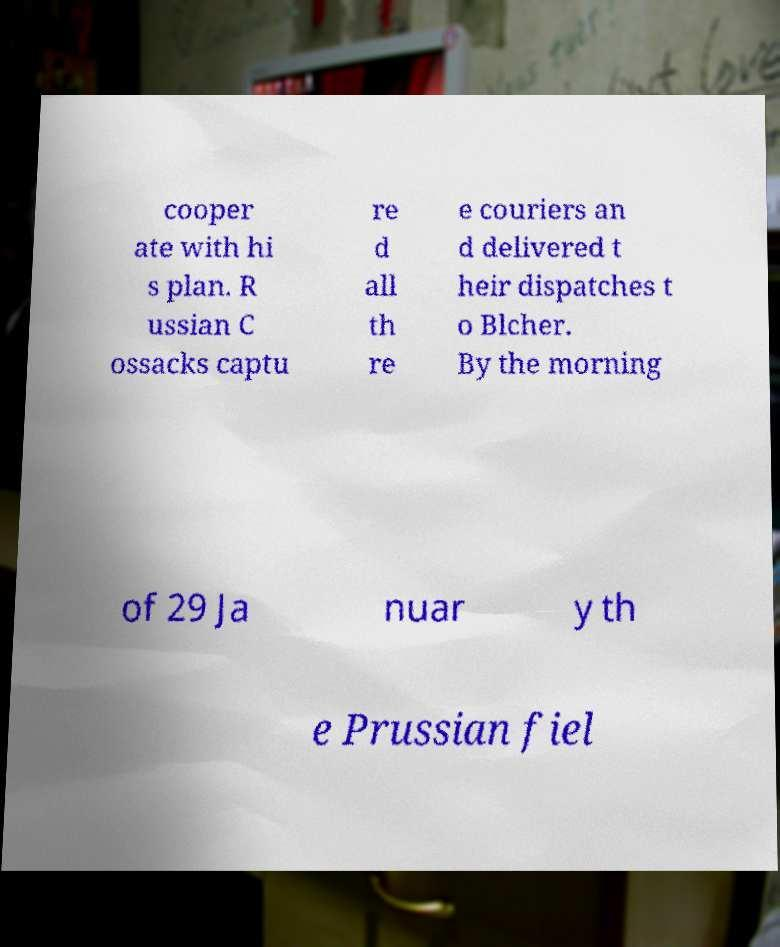What messages or text are displayed in this image? I need them in a readable, typed format. cooper ate with hi s plan. R ussian C ossacks captu re d all th re e couriers an d delivered t heir dispatches t o Blcher. By the morning of 29 Ja nuar y th e Prussian fiel 